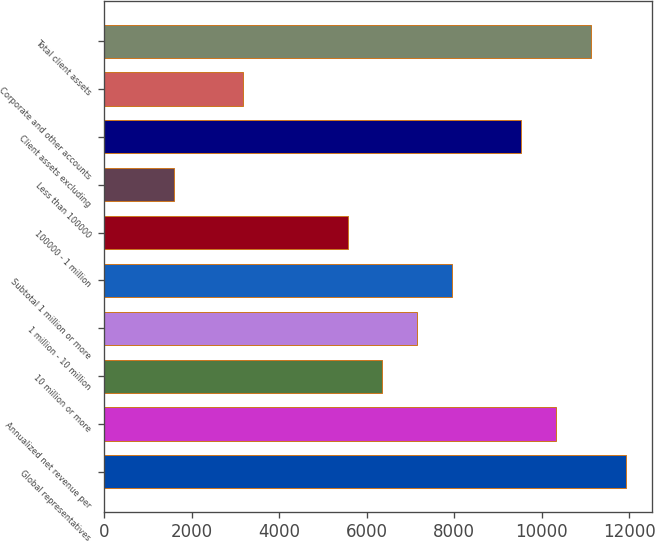Convert chart to OTSL. <chart><loc_0><loc_0><loc_500><loc_500><bar_chart><fcel>Global representatives<fcel>Annualized net revenue per<fcel>10 million or more<fcel>1 million - 10 million<fcel>Subtotal 1 million or more<fcel>100000 - 1 million<fcel>Less than 100000<fcel>Client assets excluding<fcel>Corporate and other accounts<fcel>Total client assets<nl><fcel>11911.5<fcel>10324.5<fcel>6357<fcel>7150.5<fcel>7944<fcel>5563.5<fcel>1596<fcel>9531<fcel>3183<fcel>11118<nl></chart> 